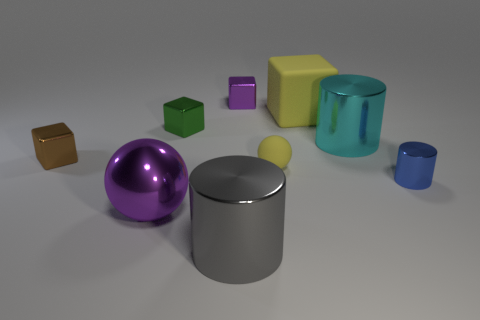Which of the objects could be described as having reflective surfaces? The objects that exhibit reflective surfaces in the image are the large and small metallic cylinders, the large purple sphere, and the small brown metallic cube. Their surfaces are shiny, indicating that they are likely made of a reflective material such as metal or polished plastic. And how does light seem to affect these reflective objects? The reflective objects catch the light, creating highlights and subtle reflections of the environment. The small brown cube and the larger cylinder in particular show bright specular highlights, while the purple sphere has softer highlights due to its curved surface. 